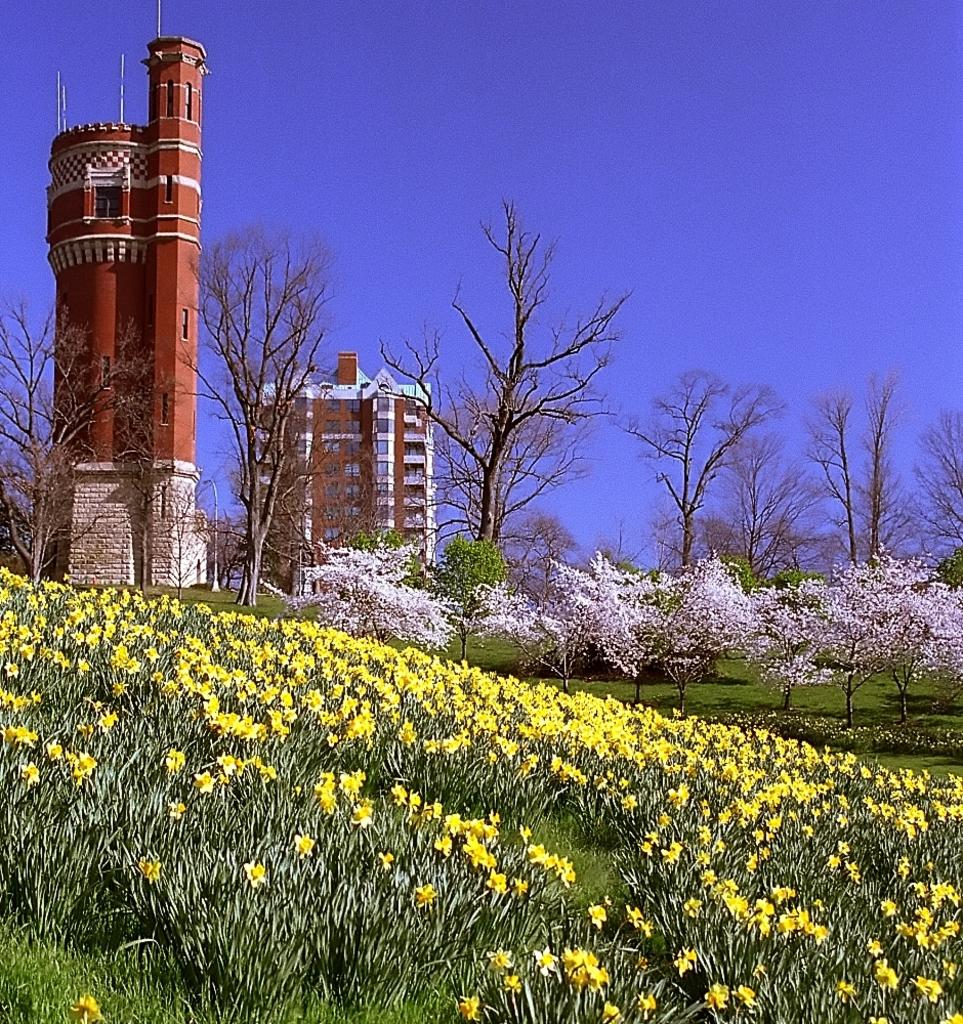What type of plants can be seen in the image? There are flowers and trees in the image. What type of vegetation is present on the ground in the image? There is grass in the image. What type of structures are visible in the image? There are buildings with windows in the image. What can be seen in the background of the image? The sky is visible in the background of the image. Can you describe the shoes worn by the woman in the image? There is no woman present in the image, so we cannot describe any shoes. 